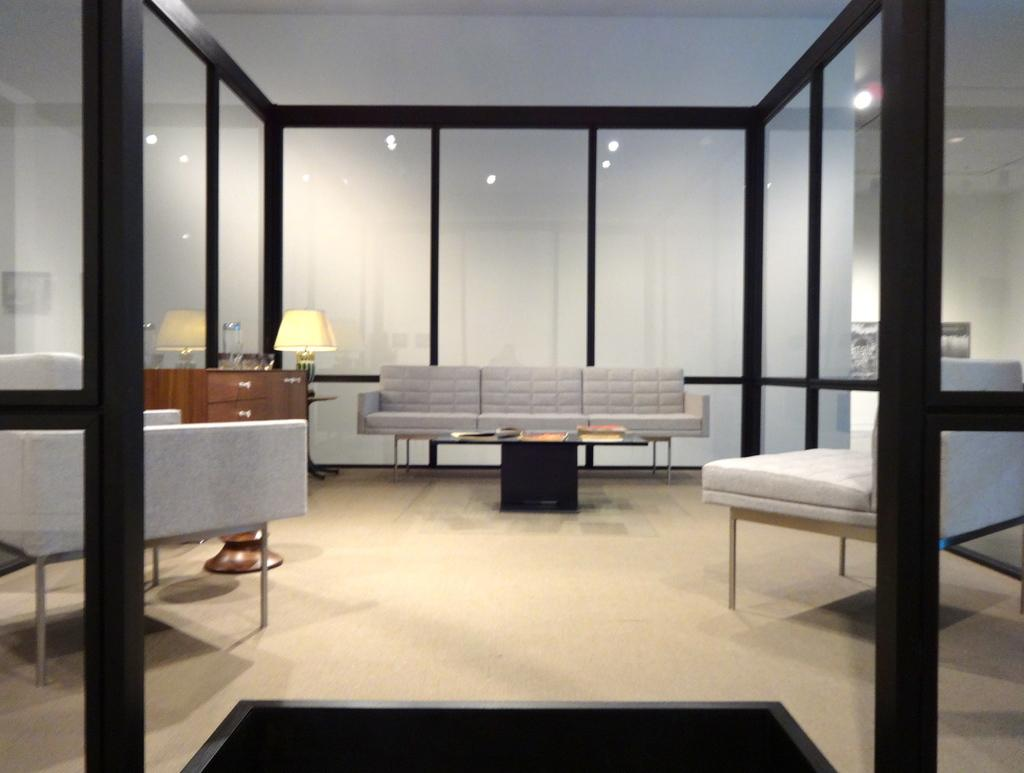What type of space is depicted in the image? There is a room in the image. What furniture is present in the room? There is a sofa, a table, and racks in the room. What lighting fixture is in the room? There is a lamp in the room. What architectural feature is unique to the room? There is a glass wall in the room. How many sheep are visible in the room? There are no sheep present in the room; the image only features a room with furniture and a glass wall. 